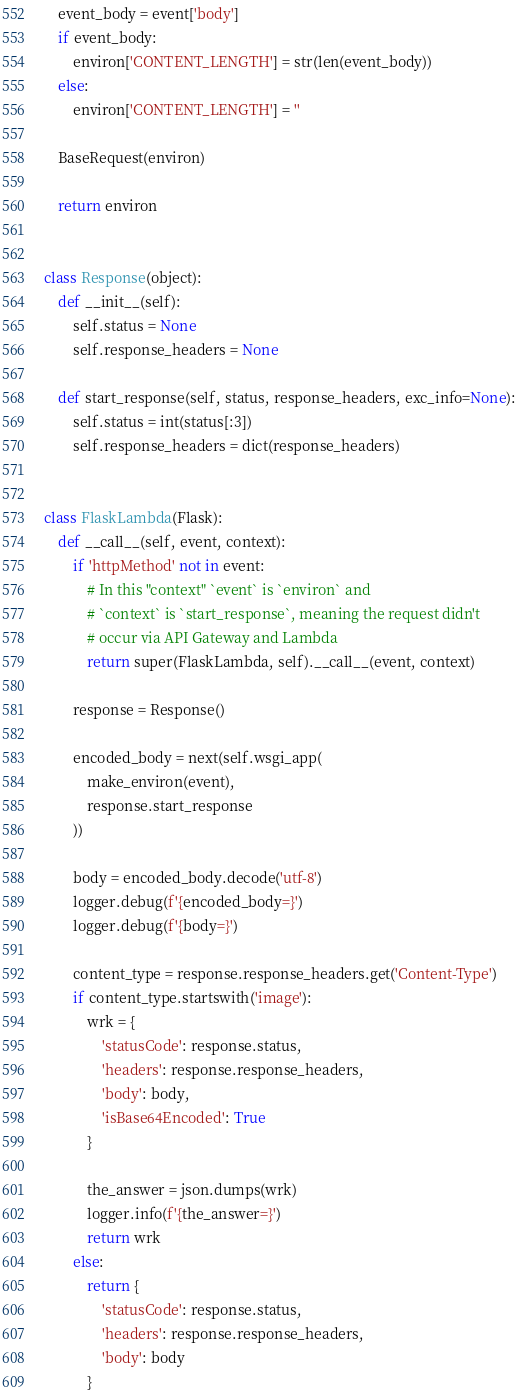Convert code to text. <code><loc_0><loc_0><loc_500><loc_500><_Python_>    event_body = event['body']
    if event_body:
        environ['CONTENT_LENGTH'] = str(len(event_body))
    else:
        environ['CONTENT_LENGTH'] = ''

    BaseRequest(environ)

    return environ


class Response(object):
    def __init__(self):
        self.status = None
        self.response_headers = None

    def start_response(self, status, response_headers, exc_info=None):
        self.status = int(status[:3])
        self.response_headers = dict(response_headers)


class FlaskLambda(Flask):
    def __call__(self, event, context):
        if 'httpMethod' not in event:
            # In this "context" `event` is `environ` and
            # `context` is `start_response`, meaning the request didn't
            # occur via API Gateway and Lambda
            return super(FlaskLambda, self).__call__(event, context)

        response = Response()

        encoded_body = next(self.wsgi_app(
            make_environ(event),
            response.start_response
        ))

        body = encoded_body.decode('utf-8')
        logger.debug(f'{encoded_body=}')
        logger.debug(f'{body=}')

        content_type = response.response_headers.get('Content-Type')
        if content_type.startswith('image'):
            wrk = {
                'statusCode': response.status,
                'headers': response.response_headers,
                'body': body,
                'isBase64Encoded': True
            }

            the_answer = json.dumps(wrk)
            logger.info(f'{the_answer=}')
            return wrk
        else:
            return {
                'statusCode': response.status,
                'headers': response.response_headers,
                'body': body
            }
</code> 